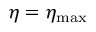<formula> <loc_0><loc_0><loc_500><loc_500>\eta = \eta _ { \max }</formula> 